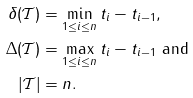<formula> <loc_0><loc_0><loc_500><loc_500>\delta ( \mathcal { T } ) & = \min _ { 1 \leq i \leq n } t _ { i } - t _ { i - 1 } , \\ \Delta ( \mathcal { T } ) & = \max _ { 1 \leq i \leq n } t _ { i } - t _ { i - 1 } \text { and } \\ | \mathcal { T } | & = n .</formula> 